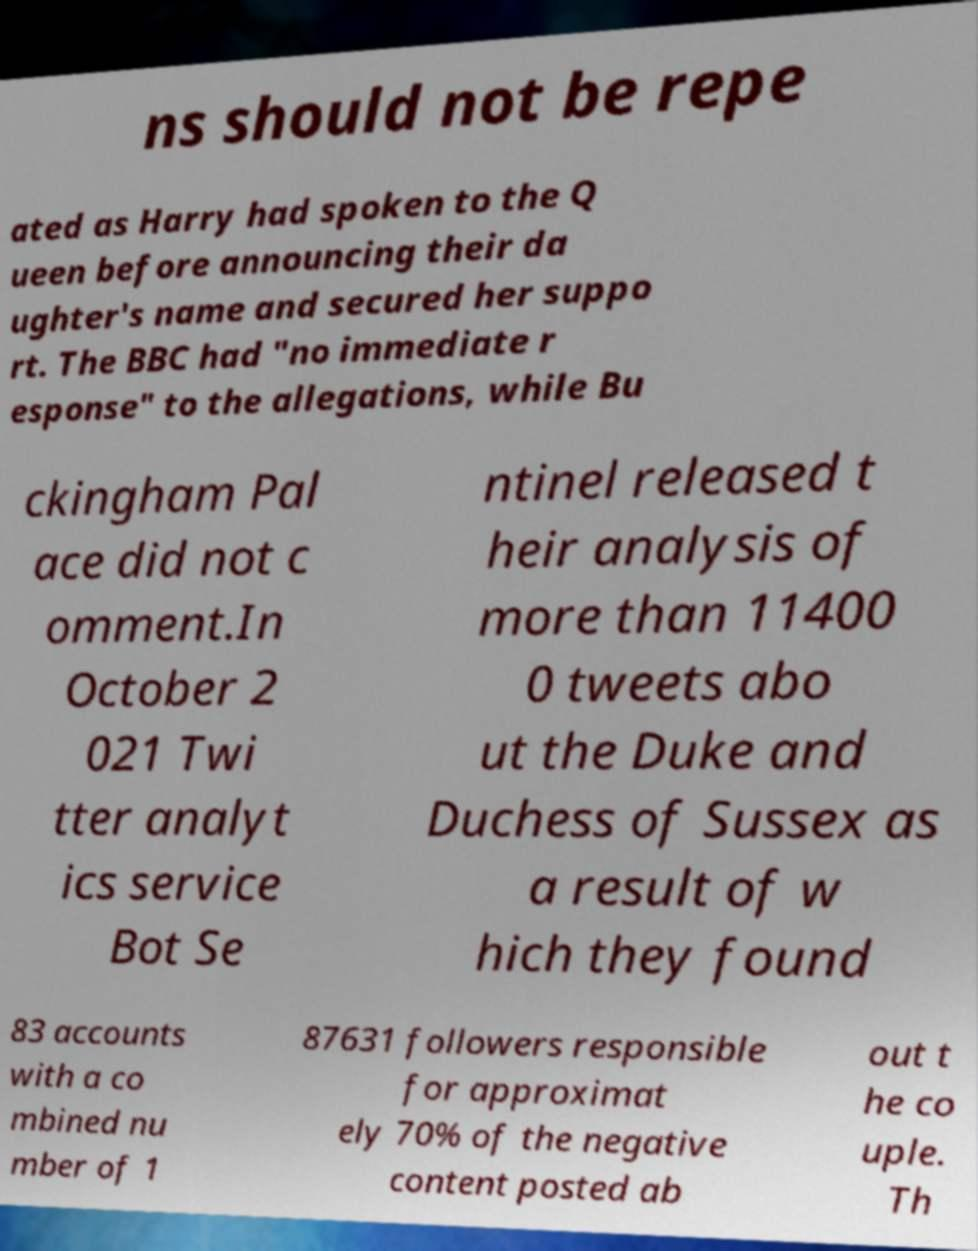There's text embedded in this image that I need extracted. Can you transcribe it verbatim? ns should not be repe ated as Harry had spoken to the Q ueen before announcing their da ughter's name and secured her suppo rt. The BBC had "no immediate r esponse" to the allegations, while Bu ckingham Pal ace did not c omment.In October 2 021 Twi tter analyt ics service Bot Se ntinel released t heir analysis of more than 11400 0 tweets abo ut the Duke and Duchess of Sussex as a result of w hich they found 83 accounts with a co mbined nu mber of 1 87631 followers responsible for approximat ely 70% of the negative content posted ab out t he co uple. Th 